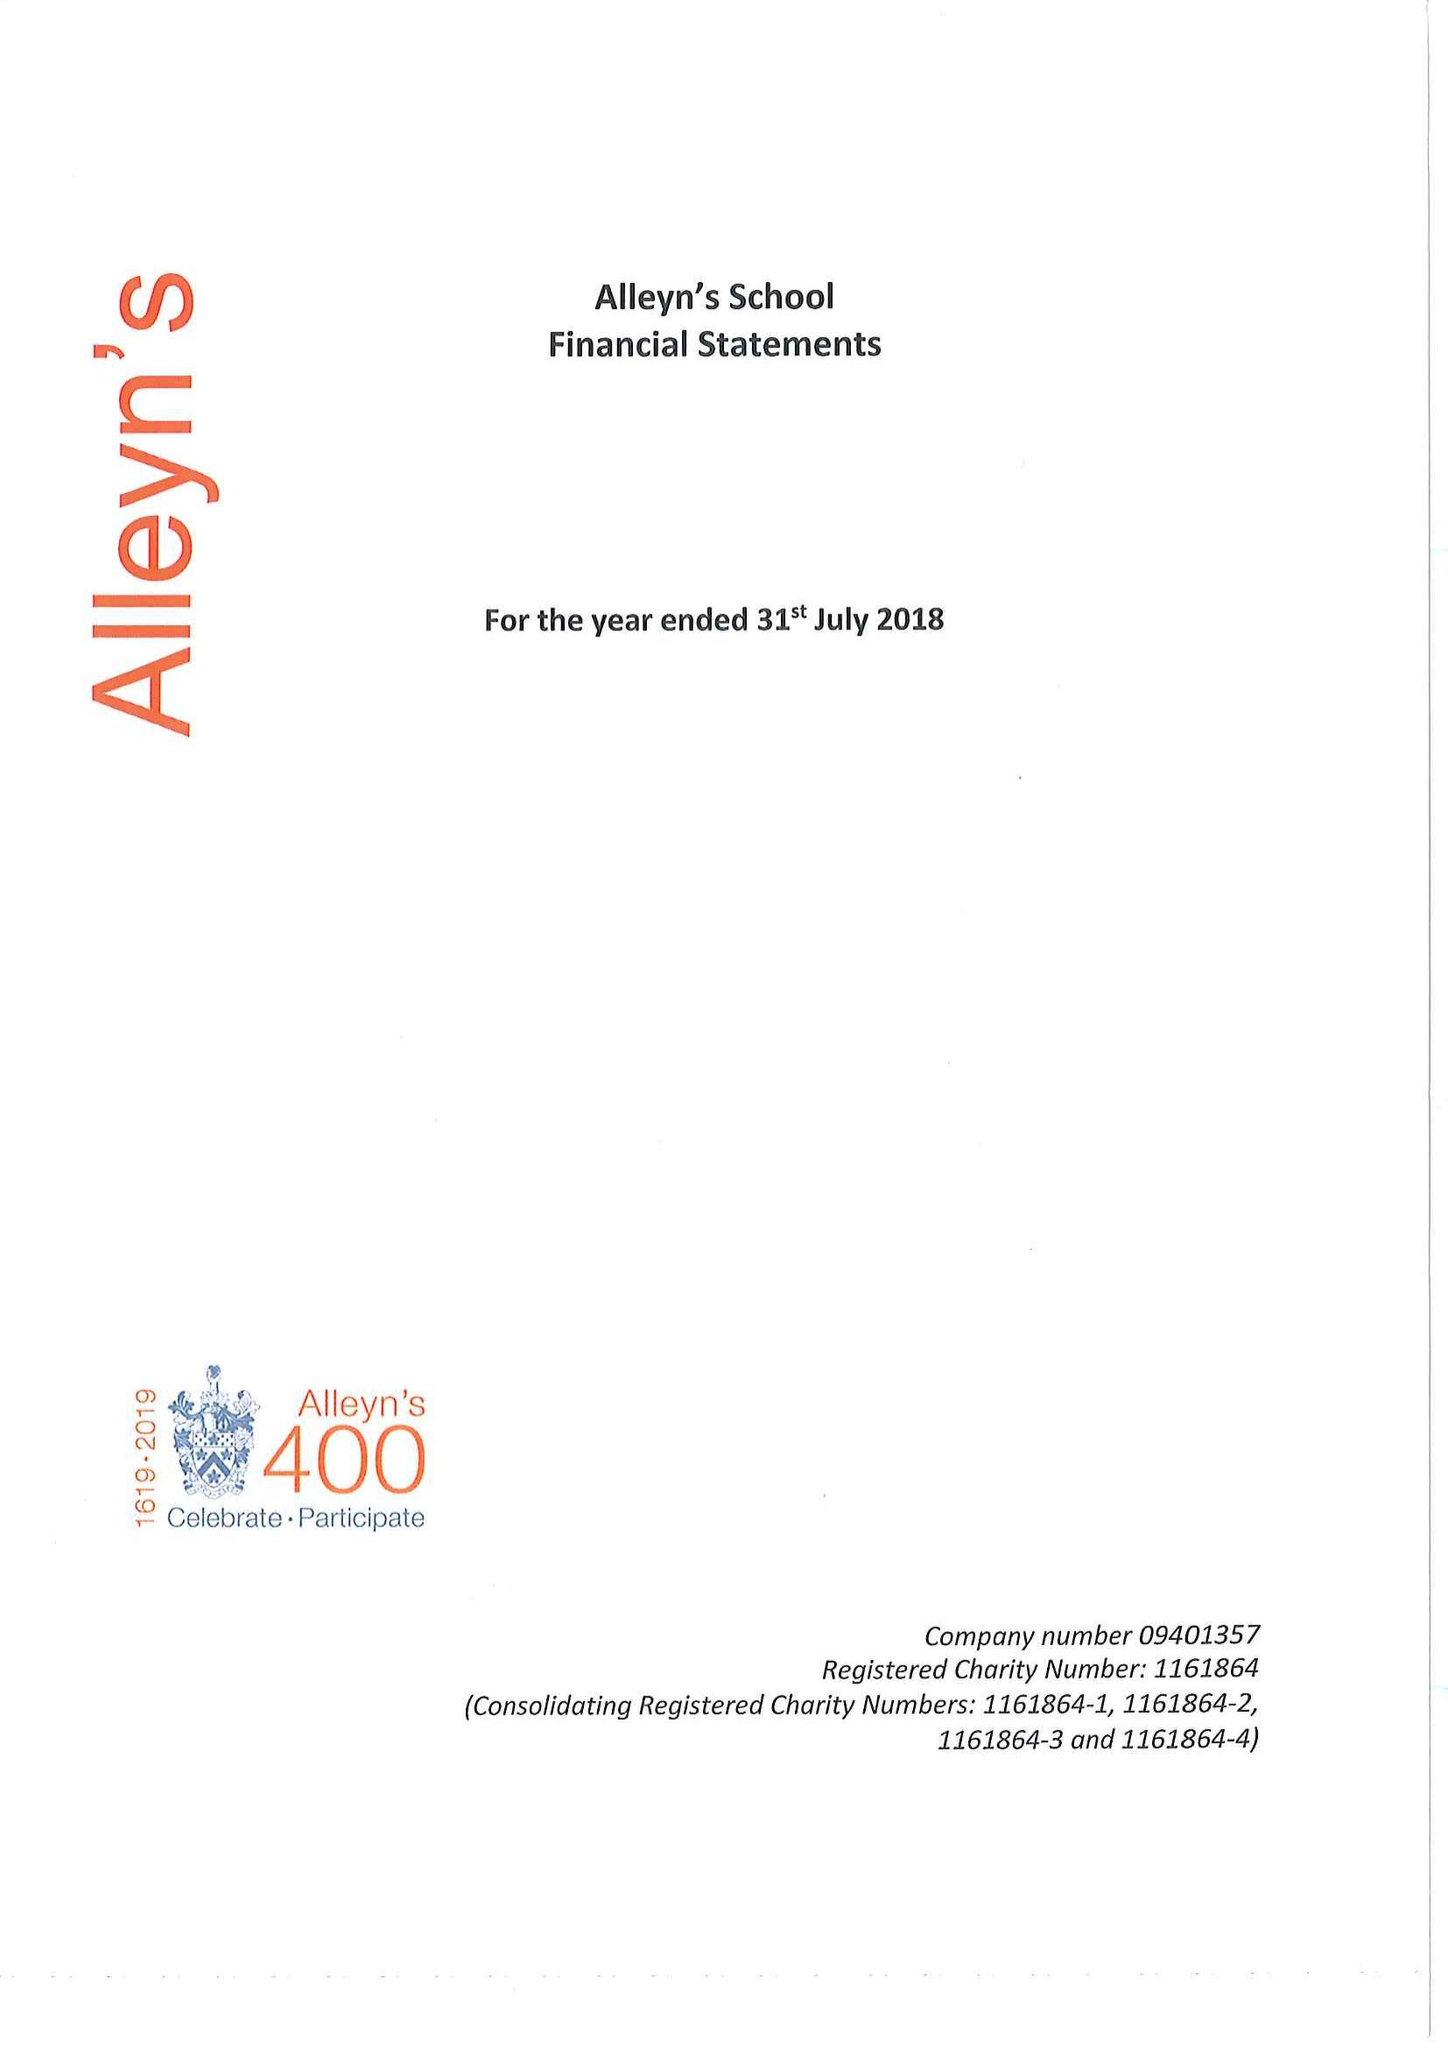What is the value for the spending_annually_in_british_pounds?
Answer the question using a single word or phrase. 23984000.00 